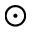Convert formula to latex. <formula><loc_0><loc_0><loc_500><loc_500>\odot</formula> 